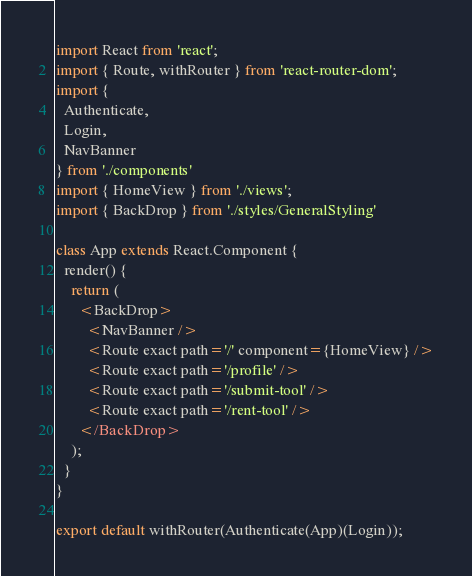<code> <loc_0><loc_0><loc_500><loc_500><_JavaScript_>import React from 'react';
import { Route, withRouter } from 'react-router-dom';
import {
  Authenticate,
  Login,
  NavBanner
} from './components'
import { HomeView } from './views';
import { BackDrop } from './styles/GeneralStyling'

class App extends React.Component {
  render() {
    return (
      <BackDrop>
        <NavBanner />
        <Route exact path='/' component={HomeView} />
        <Route exact path='/profile' />
        <Route exact path='/submit-tool' />
        <Route exact path='/rent-tool' />
      </BackDrop>
    );
  }
}

export default withRouter(Authenticate(App)(Login));</code> 